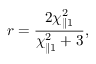<formula> <loc_0><loc_0><loc_500><loc_500>r = \frac { 2 \chi _ { \| 1 } ^ { 2 } } { \chi _ { \| 1 } ^ { 2 } + 3 } ,</formula> 